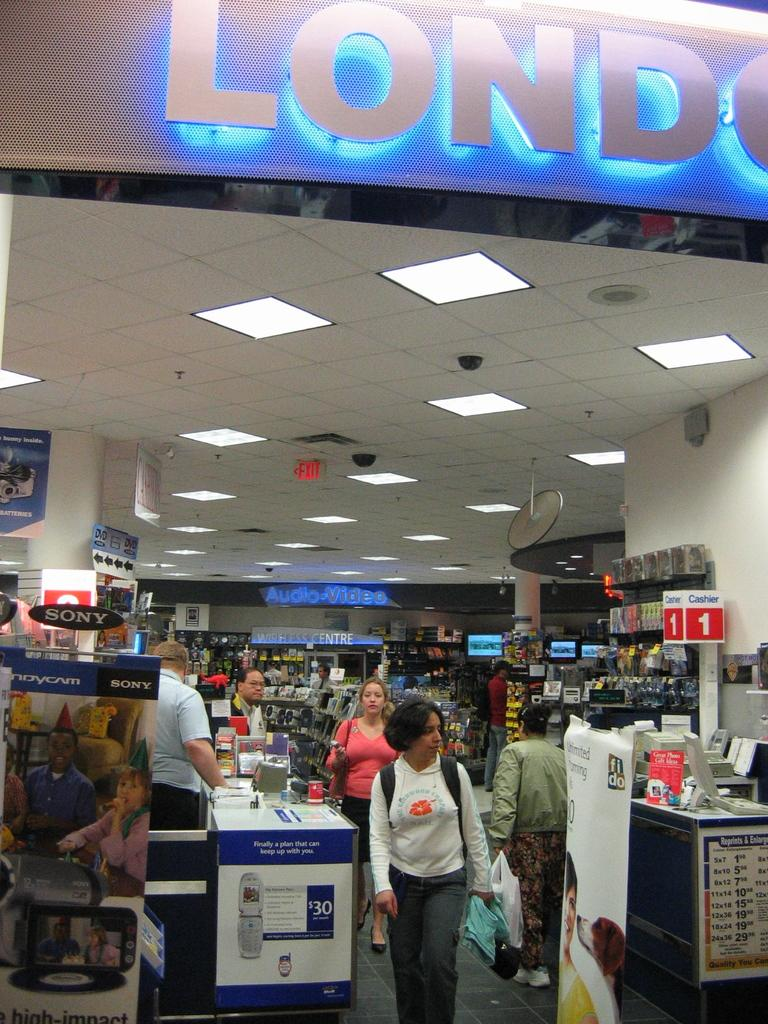<image>
Create a compact narrative representing the image presented. People shopping in a store, with the words Audio Video lit up 